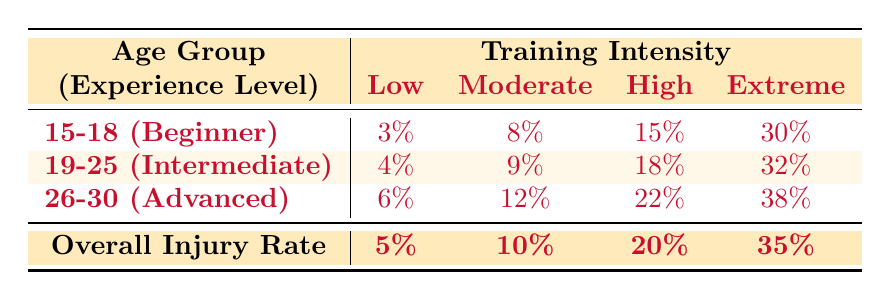What is the injury rate for players aged 15-18 under high training intensity? According to the table, the injury rate for players in the age group of 15-18 at high training intensity is 15%.
Answer: 15% Which training intensity level has the highest injury rate overall? The table indicates that the extreme training intensity level has the highest overall injury rate of 35%.
Answer: 35% If an intermediate player trains at moderate intensity, what is their injury rate? The table shows that the injury rate for intermediate players training at moderate intensity is 9%.
Answer: 9% Is the injury rate higher for advanced players under extreme training intensity compared to beginner players under the same intensity? Yes, the injury rate for advanced players under extreme training intensity is 38%, while for beginner players, it is 30%.
Answer: Yes What is the average injury rate for players in the age group of 19-25 across all training intensities? The injury rates for this group are 4%, 9%, 18%, and 32%. Adding these rates gives 63%, and dividing by 4 (the number of training intensities) results in an average injury rate of 15.75%.
Answer: 15.75% 